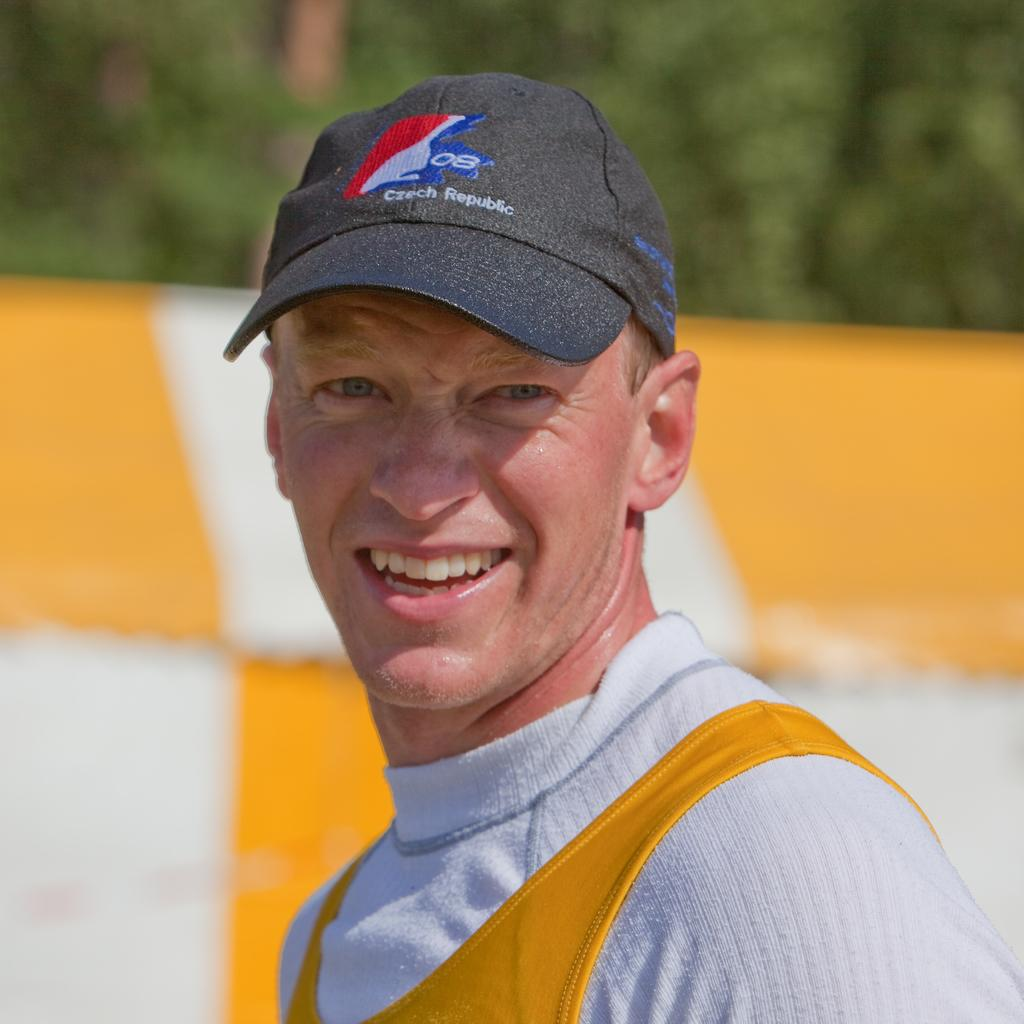<image>
Relay a brief, clear account of the picture shown. a hat that has the Czech Republic on it 